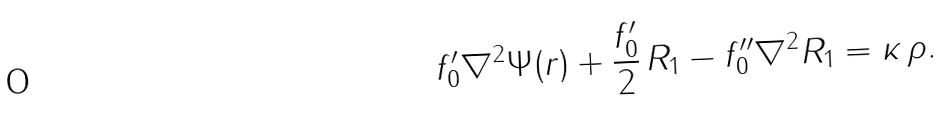<formula> <loc_0><loc_0><loc_500><loc_500>f _ { 0 } ^ { \prime } \nabla ^ { 2 } \Psi ( r ) + \frac { f _ { 0 } ^ { \prime } } { 2 } \, R _ { 1 } - f _ { 0 } ^ { \prime \prime } \nabla ^ { 2 } R _ { 1 } = \kappa \, \rho .</formula> 